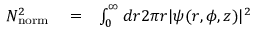Convert formula to latex. <formula><loc_0><loc_0><loc_500><loc_500>\begin{array} { r l r } { N _ { n o r m } ^ { 2 } } & = } & { \int _ { 0 } ^ { \infty } d r 2 \pi r | \psi ( r , \phi , z ) | ^ { 2 } } \end{array}</formula> 